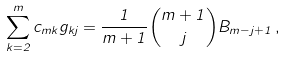Convert formula to latex. <formula><loc_0><loc_0><loc_500><loc_500>\sum _ { k = 2 } ^ { m } c _ { m k } g _ { k j } = \frac { 1 } { m + 1 } { m + 1 \choose j } B _ { m - j + 1 } \, ,</formula> 